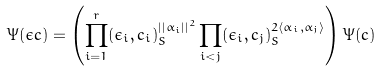<formula> <loc_0><loc_0><loc_500><loc_500>\Psi ( \epsilon c ) = \left ( \prod _ { i = 1 } ^ { r } ( \epsilon _ { i } , c _ { i } ) _ { S } ^ { | | \alpha _ { i } | | ^ { 2 } } \prod _ { i < j } ( \epsilon _ { i } , c _ { j } ) _ { S } ^ { 2 \langle \alpha _ { i } , \alpha _ { j } \rangle } \right ) \Psi ( c )</formula> 